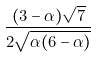<formula> <loc_0><loc_0><loc_500><loc_500>\frac { ( 3 - \alpha ) { \sqrt { 7 } } } { 2 { \sqrt { \alpha ( 6 - \alpha ) } } }</formula> 